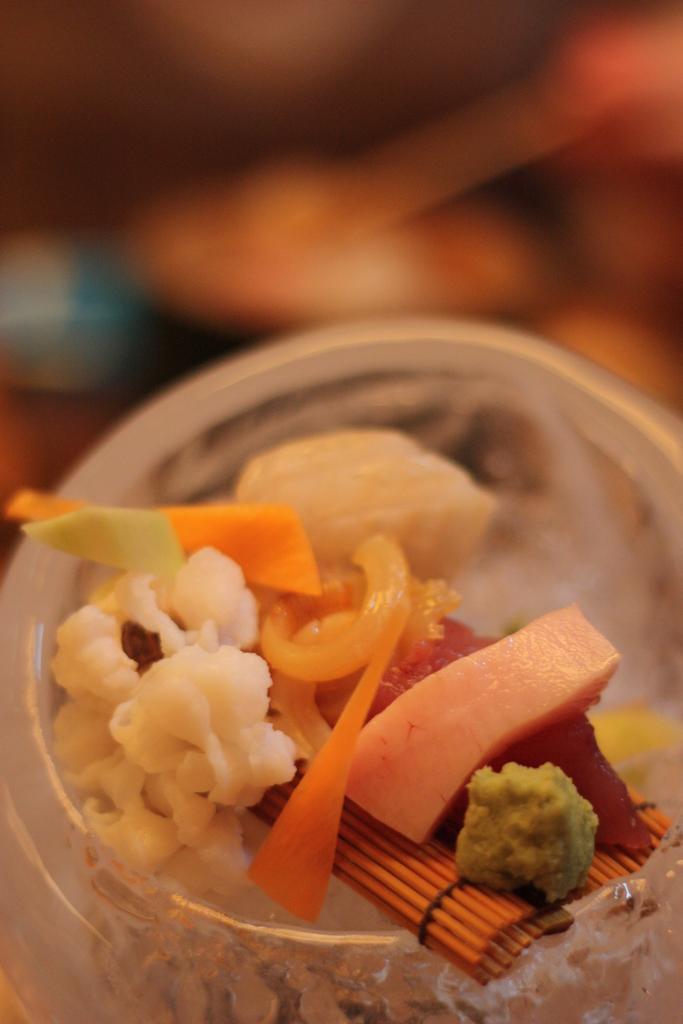In one or two sentences, can you explain what this image depicts? In this image we can see some food item inside a bowl with blur background. 